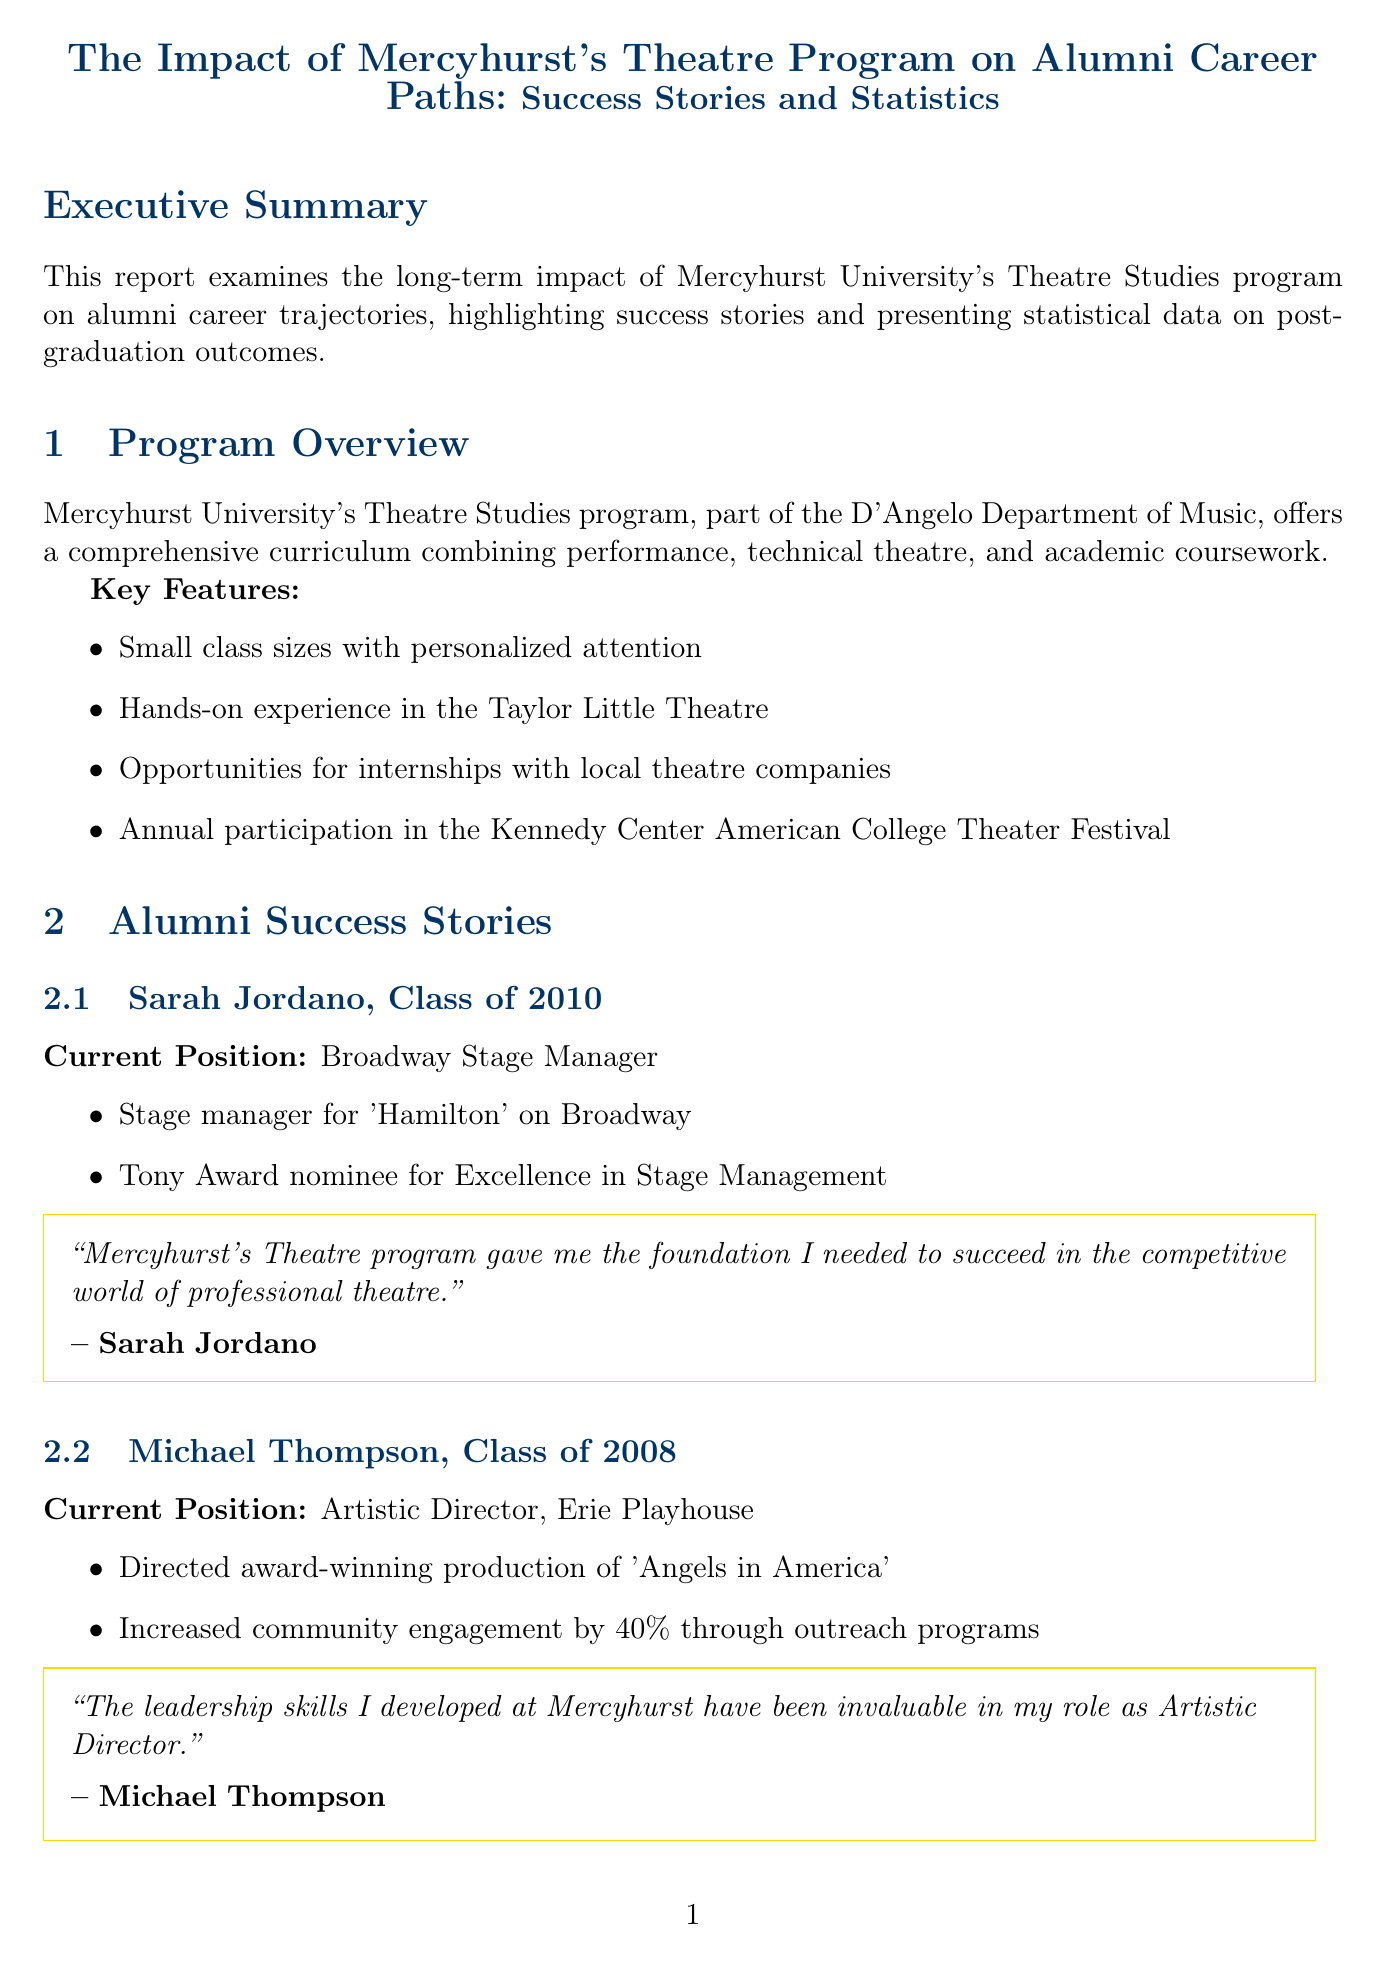What is the employment rate of Theatre Studies graduates? The employment rate is given in the statistics section of the report, indicating the percentage of graduates who are employed or in graduate school within six months of graduation.
Answer: 92% Who is the current position of Emily Chen? The report includes success stories of alumni, which details their current positions in the entertainment industry.
Answer: Costume Designer, Netflix What year did Michael Thompson graduate? The graduation years of featured alumni are mentioned in their respective sections of the report.
Answer: 2008 What percentage of graduates pursue advanced degrees? This statistic is highlighted in the career statistics section of the report, showing the proportion of graduates who continue their education.
Answer: 25% What skill is listed under the skills developed by the program? The report outlines various skills that graduates develop through the program, which helps them in their careers.
Answer: Creative problem-solving Which play did Michael Thompson direct that won awards? Notable achievements of alumni are described in the success stories of the report, illustrating their contributions to theatre.
Answer: Angels in America What initiative did Emily Chen launch? The report includes notable achievements of the alumni, highlighting their innovative contributions to the industry.
Answer: Sustainable costuming initiative for streaming productions How many alumni are featured in the report? The document lists the number of spotlighted success stories in the alumni section.
Answer: Three What is a future initiative mentioned for the Theatre program? Future initiatives are discussed towards the end of the report, which outlines plans for program development.
Answer: Expansion of digital media and virtual performance curriculum 